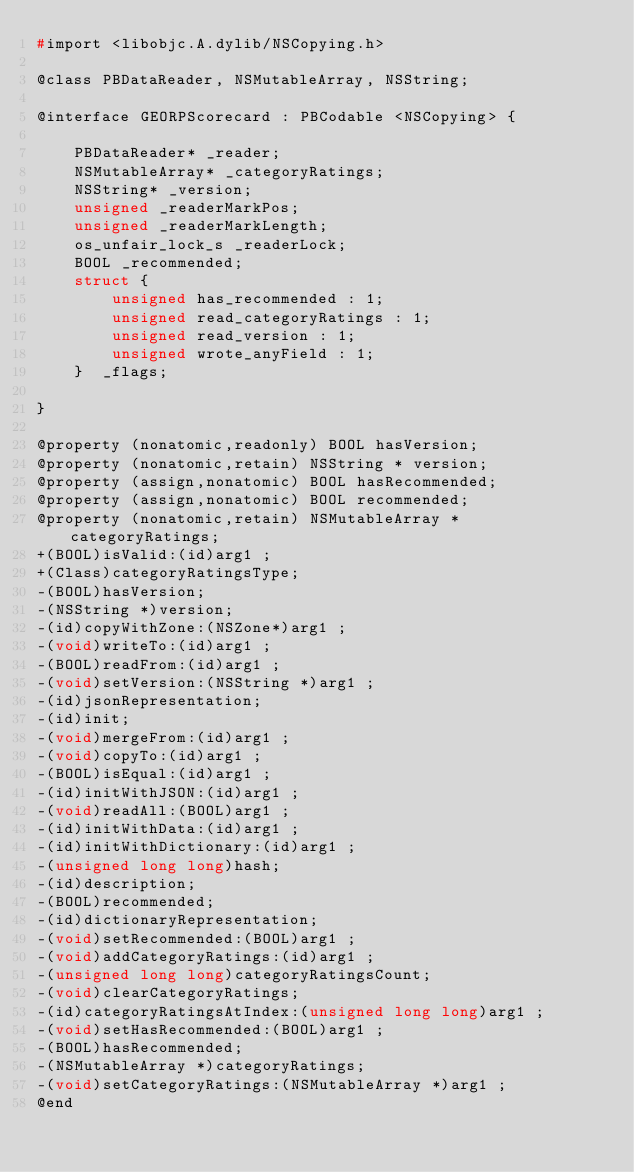Convert code to text. <code><loc_0><loc_0><loc_500><loc_500><_C_>#import <libobjc.A.dylib/NSCopying.h>

@class PBDataReader, NSMutableArray, NSString;

@interface GEORPScorecard : PBCodable <NSCopying> {

	PBDataReader* _reader;
	NSMutableArray* _categoryRatings;
	NSString* _version;
	unsigned _readerMarkPos;
	unsigned _readerMarkLength;
	os_unfair_lock_s _readerLock;
	BOOL _recommended;
	struct {
		unsigned has_recommended : 1;
		unsigned read_categoryRatings : 1;
		unsigned read_version : 1;
		unsigned wrote_anyField : 1;
	}  _flags;

}

@property (nonatomic,readonly) BOOL hasVersion; 
@property (nonatomic,retain) NSString * version; 
@property (assign,nonatomic) BOOL hasRecommended; 
@property (assign,nonatomic) BOOL recommended; 
@property (nonatomic,retain) NSMutableArray * categoryRatings; 
+(BOOL)isValid:(id)arg1 ;
+(Class)categoryRatingsType;
-(BOOL)hasVersion;
-(NSString *)version;
-(id)copyWithZone:(NSZone*)arg1 ;
-(void)writeTo:(id)arg1 ;
-(BOOL)readFrom:(id)arg1 ;
-(void)setVersion:(NSString *)arg1 ;
-(id)jsonRepresentation;
-(id)init;
-(void)mergeFrom:(id)arg1 ;
-(void)copyTo:(id)arg1 ;
-(BOOL)isEqual:(id)arg1 ;
-(id)initWithJSON:(id)arg1 ;
-(void)readAll:(BOOL)arg1 ;
-(id)initWithData:(id)arg1 ;
-(id)initWithDictionary:(id)arg1 ;
-(unsigned long long)hash;
-(id)description;
-(BOOL)recommended;
-(id)dictionaryRepresentation;
-(void)setRecommended:(BOOL)arg1 ;
-(void)addCategoryRatings:(id)arg1 ;
-(unsigned long long)categoryRatingsCount;
-(void)clearCategoryRatings;
-(id)categoryRatingsAtIndex:(unsigned long long)arg1 ;
-(void)setHasRecommended:(BOOL)arg1 ;
-(BOOL)hasRecommended;
-(NSMutableArray *)categoryRatings;
-(void)setCategoryRatings:(NSMutableArray *)arg1 ;
@end

</code> 